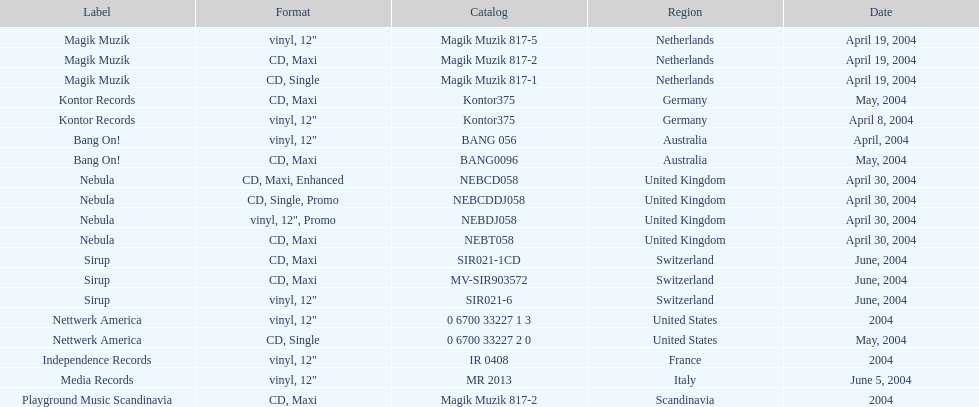Would you be able to parse every entry in this table? {'header': ['Label', 'Format', 'Catalog', 'Region', 'Date'], 'rows': [['Magik Muzik', 'vinyl, 12"', 'Magik Muzik 817-5', 'Netherlands', 'April 19, 2004'], ['Magik Muzik', 'CD, Maxi', 'Magik Muzik 817-2', 'Netherlands', 'April 19, 2004'], ['Magik Muzik', 'CD, Single', 'Magik Muzik 817-1', 'Netherlands', 'April 19, 2004'], ['Kontor Records', 'CD, Maxi', 'Kontor375', 'Germany', 'May, 2004'], ['Kontor Records', 'vinyl, 12"', 'Kontor375', 'Germany', 'April 8, 2004'], ['Bang On!', 'vinyl, 12"', 'BANG 056', 'Australia', 'April, 2004'], ['Bang On!', 'CD, Maxi', 'BANG0096', 'Australia', 'May, 2004'], ['Nebula', 'CD, Maxi, Enhanced', 'NEBCD058', 'United Kingdom', 'April 30, 2004'], ['Nebula', 'CD, Single, Promo', 'NEBCDDJ058', 'United Kingdom', 'April 30, 2004'], ['Nebula', 'vinyl, 12", Promo', 'NEBDJ058', 'United Kingdom', 'April 30, 2004'], ['Nebula', 'CD, Maxi', 'NEBT058', 'United Kingdom', 'April 30, 2004'], ['Sirup', 'CD, Maxi', 'SIR021-1CD', 'Switzerland', 'June, 2004'], ['Sirup', 'CD, Maxi', 'MV-SIR903572', 'Switzerland', 'June, 2004'], ['Sirup', 'vinyl, 12"', 'SIR021-6', 'Switzerland', 'June, 2004'], ['Nettwerk America', 'vinyl, 12"', '0 6700 33227 1 3', 'United States', '2004'], ['Nettwerk America', 'CD, Single', '0 6700 33227 2 0', 'United States', 'May, 2004'], ['Independence Records', 'vinyl, 12"', 'IR 0408', 'France', '2004'], ['Media Records', 'vinyl, 12"', 'MR 2013', 'Italy', 'June 5, 2004'], ['Playground Music Scandinavia', 'CD, Maxi', 'Magik Muzik 817-2', 'Scandinavia', '2004']]} How many catalogs were released? 19. 